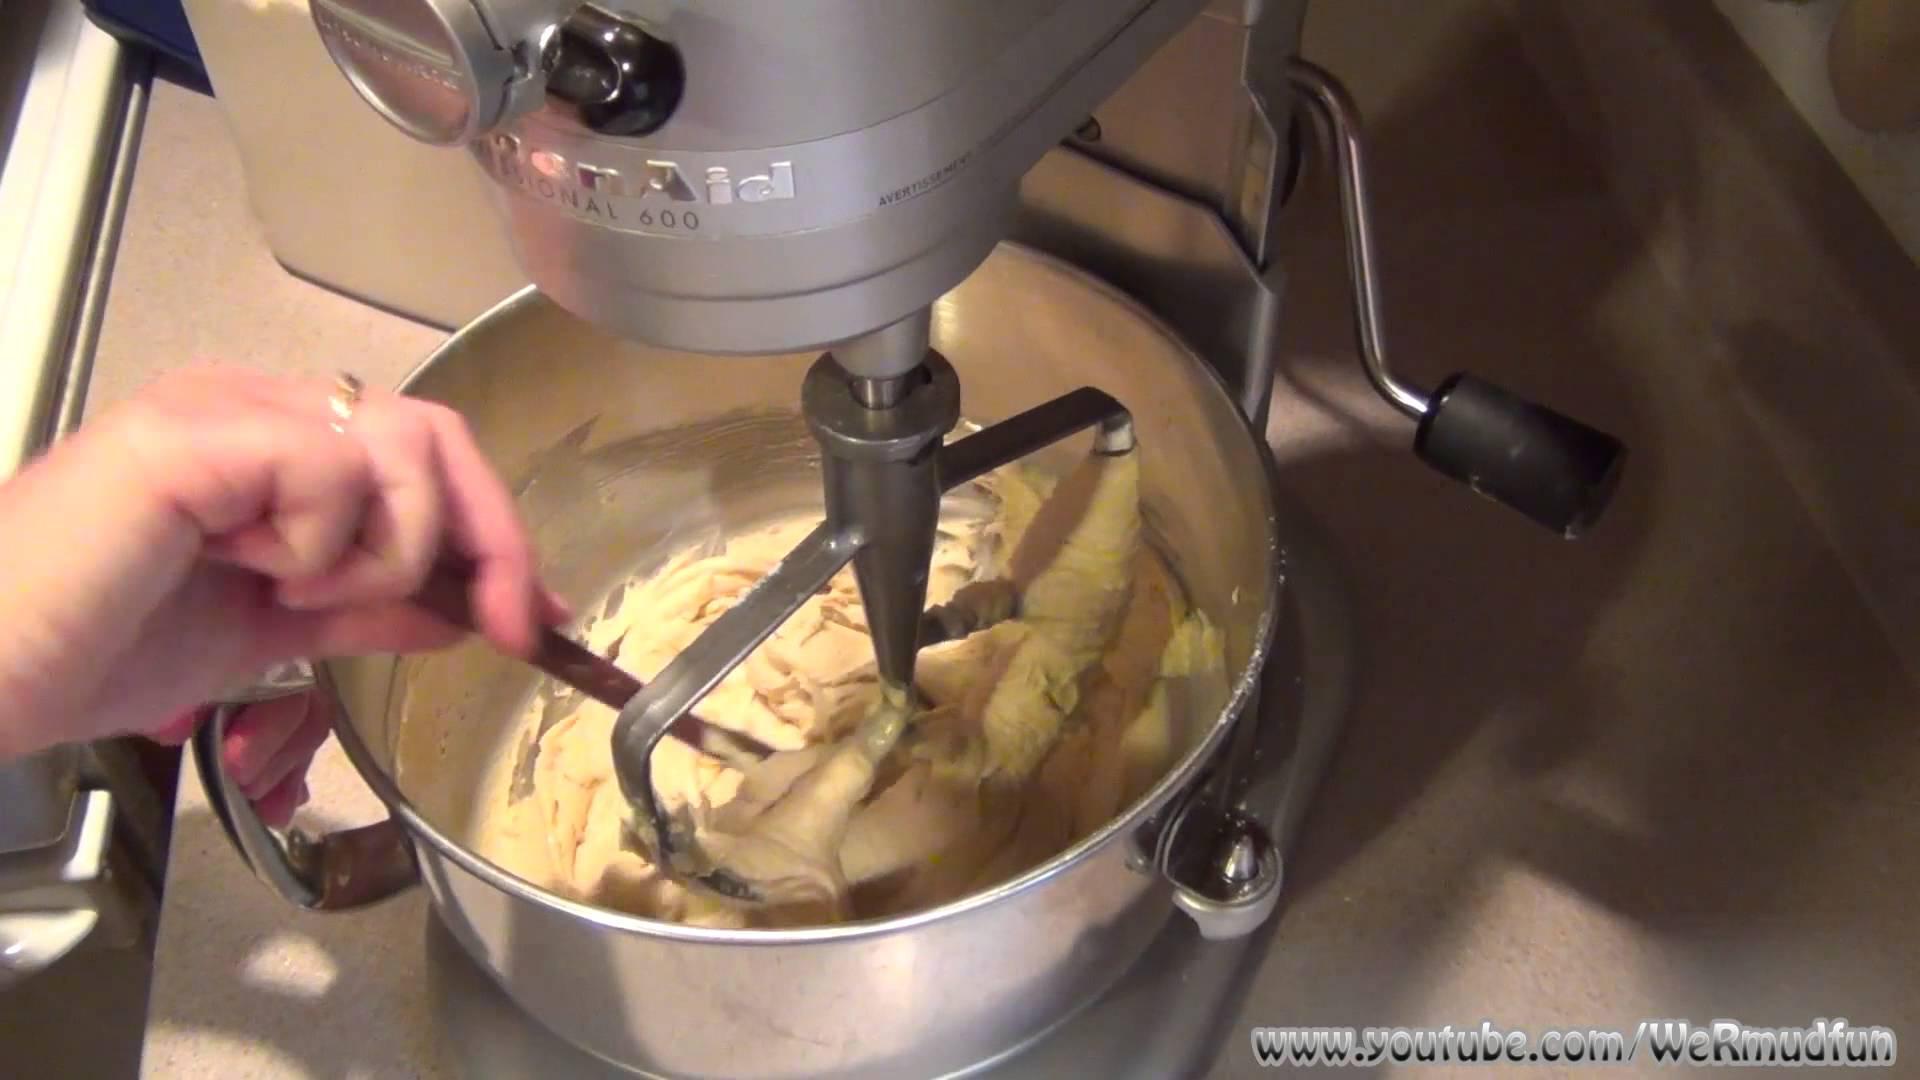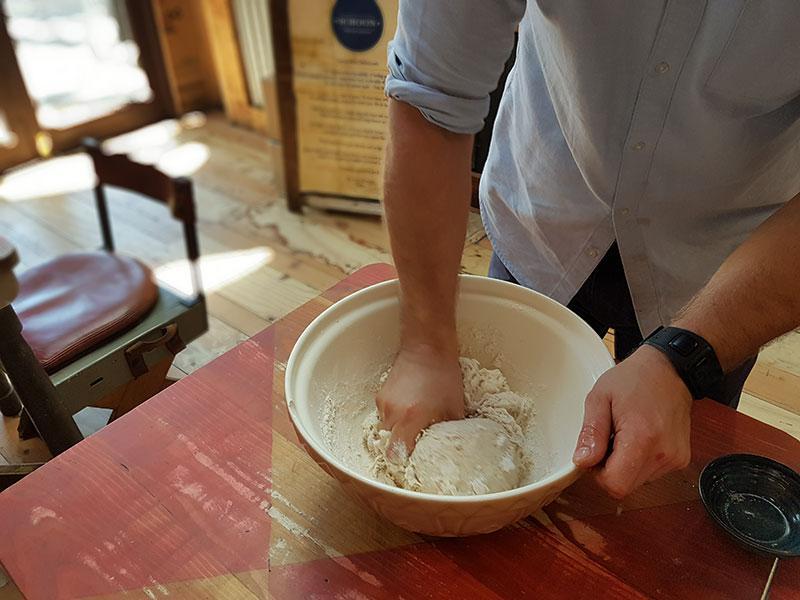The first image is the image on the left, the second image is the image on the right. Given the left and right images, does the statement "The right image shows one hand holding a spoon in a silver-colored bowl as the other hand grips the edge of the bowl." hold true? Answer yes or no. No. The first image is the image on the left, the second image is the image on the right. Examine the images to the left and right. Is the description "In one of the images, the person's hand is pouring an ingredient into the bowl." accurate? Answer yes or no. No. 